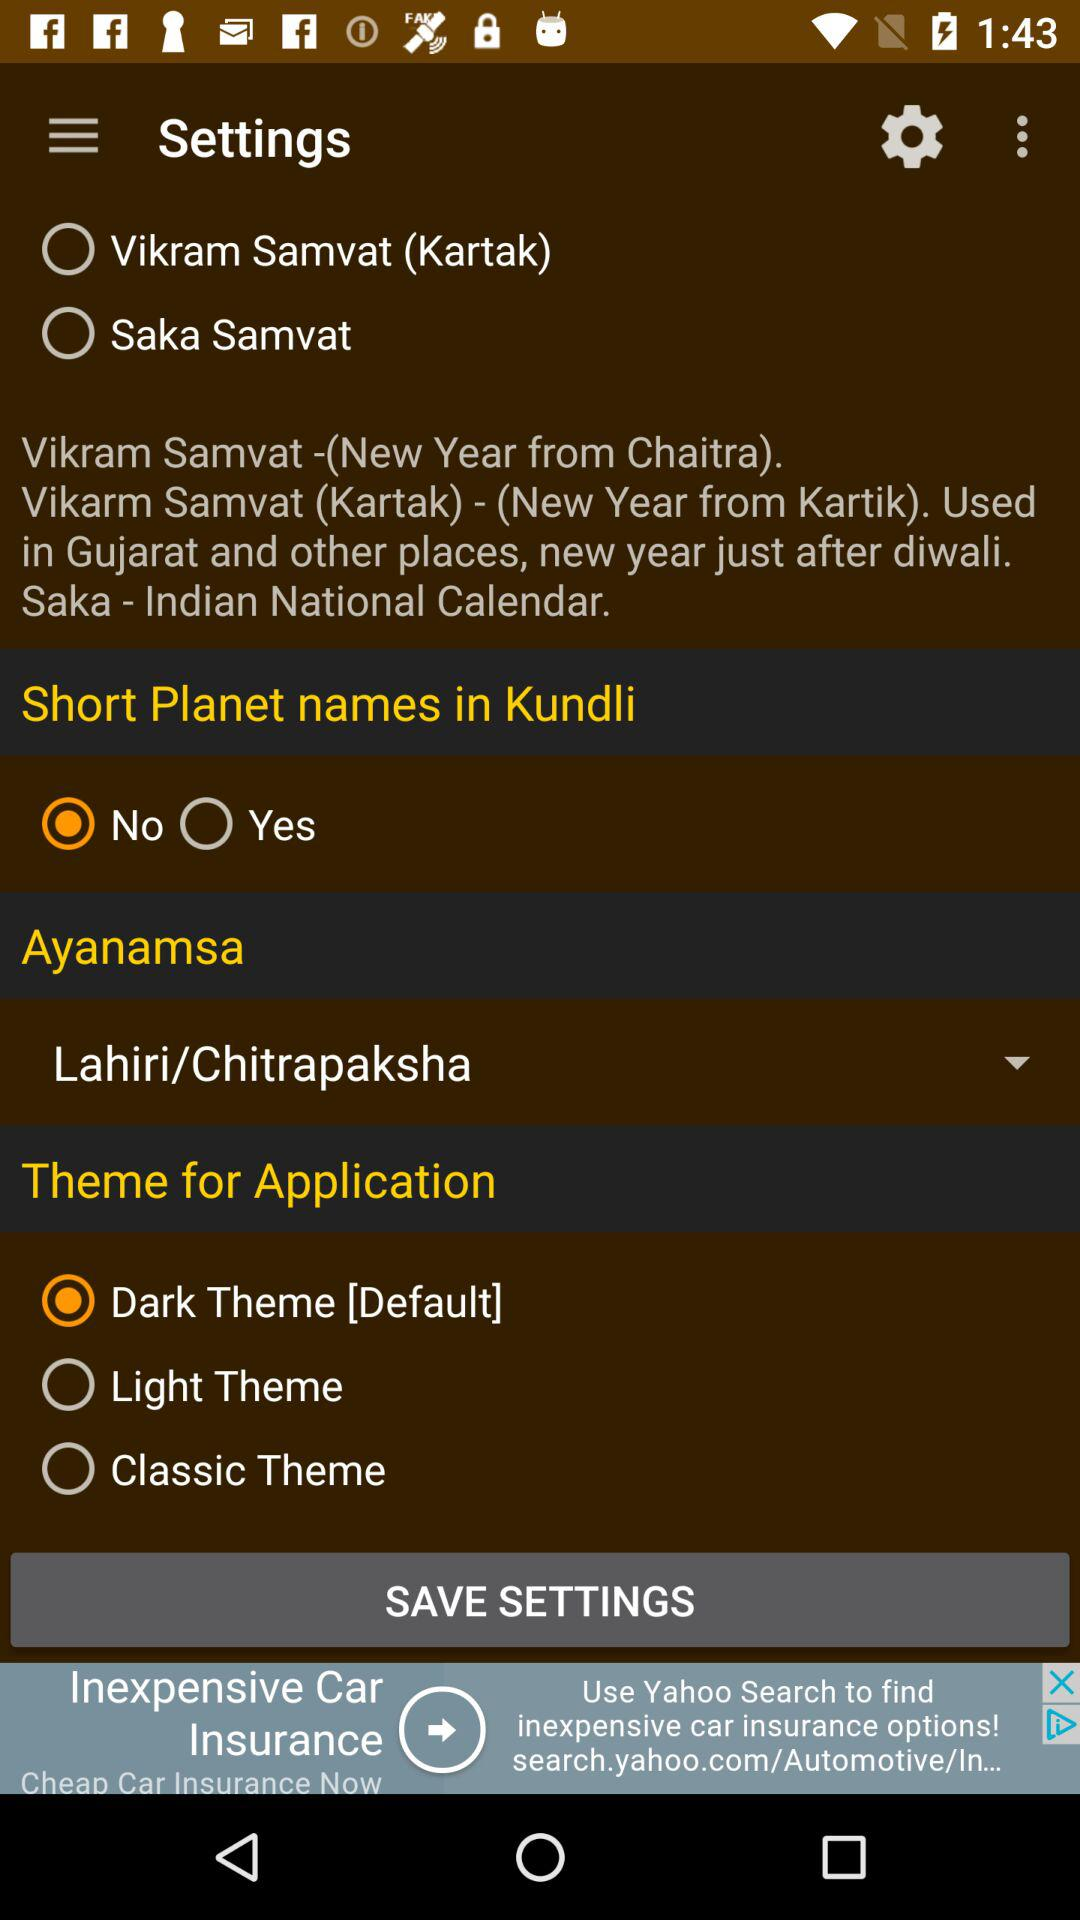What is the name of the Indian National Calendar? The name of the Indian National Calendar is "Saka". 